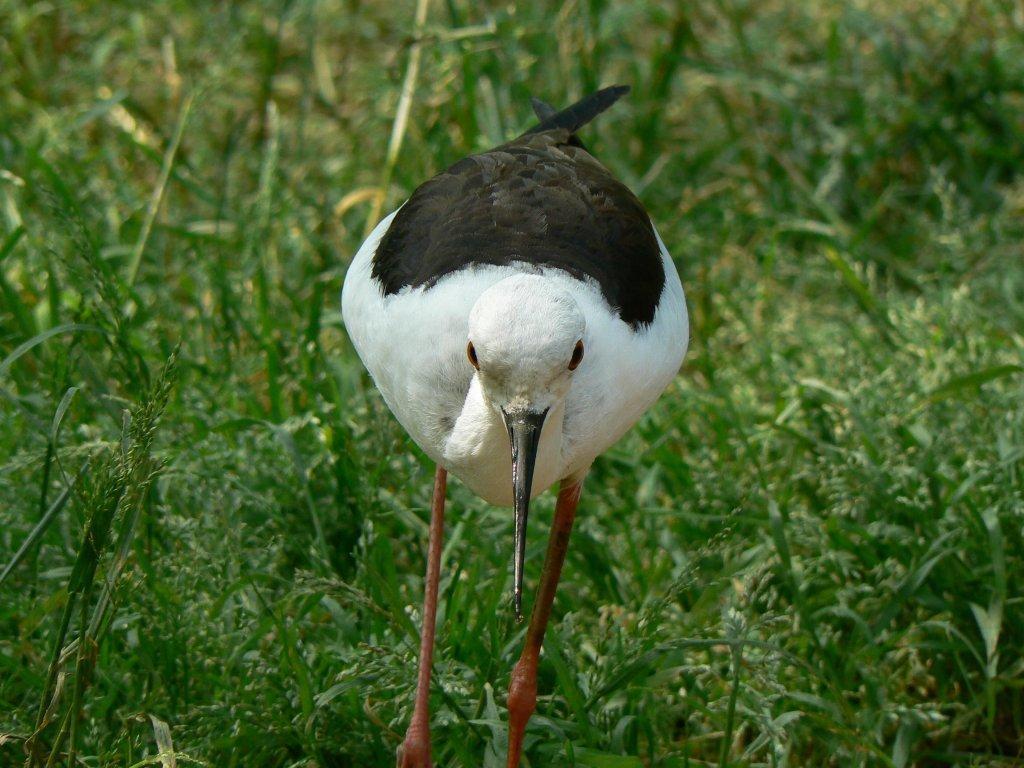Please provide a concise description of this image. In this picture in the middle, we can see a bird standing on the grass. In the background, we can see a grass which is in green color. 